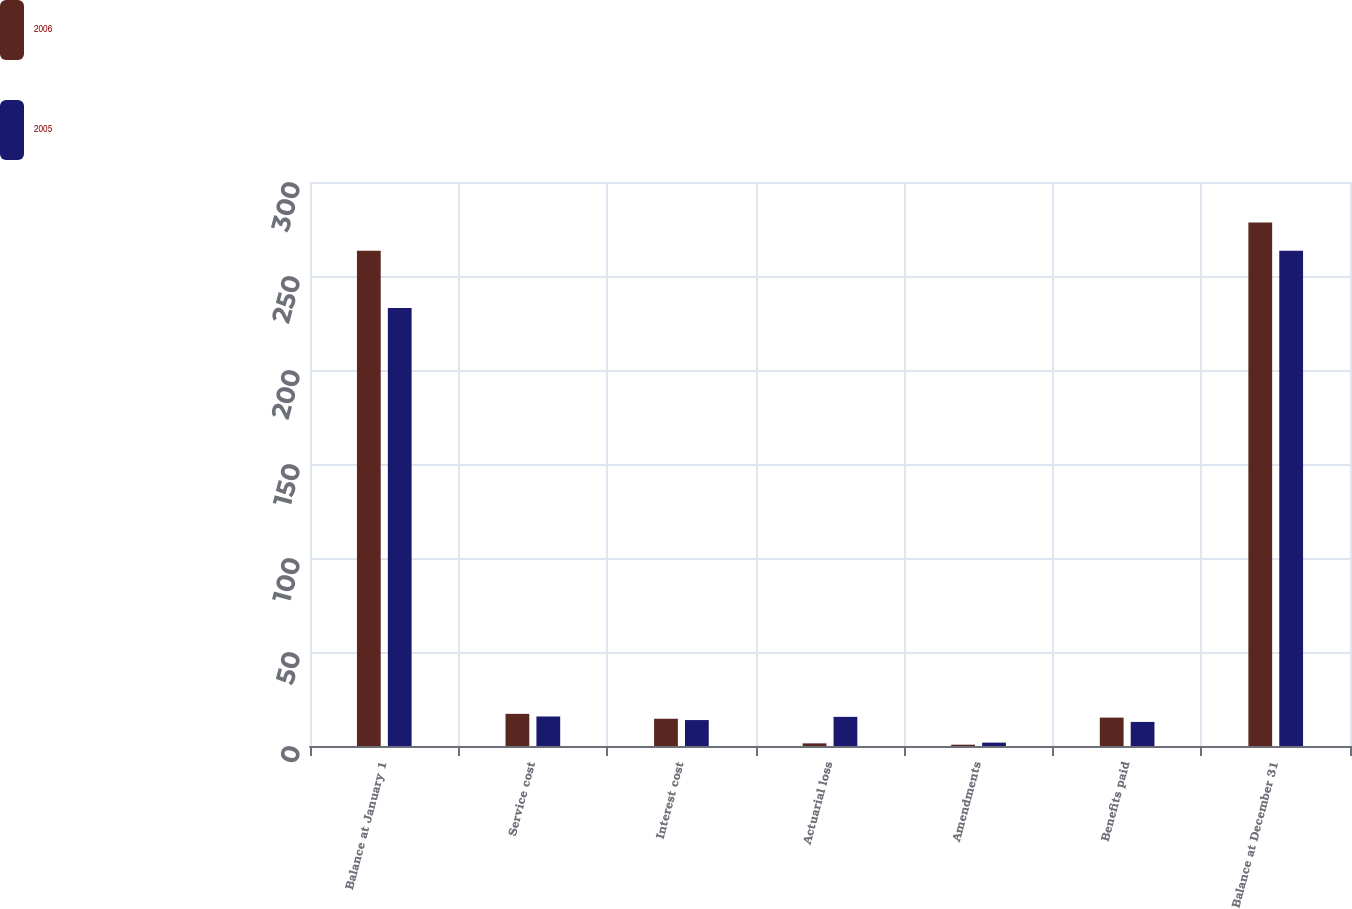Convert chart. <chart><loc_0><loc_0><loc_500><loc_500><stacked_bar_chart><ecel><fcel>Balance at January 1<fcel>Service cost<fcel>Interest cost<fcel>Actuarial loss<fcel>Amendments<fcel>Benefits paid<fcel>Balance at December 31<nl><fcel>2006<fcel>263.4<fcel>17.1<fcel>14.5<fcel>1.4<fcel>0.7<fcel>15.1<fcel>278.5<nl><fcel>2005<fcel>233<fcel>15.7<fcel>13.8<fcel>15.5<fcel>1.8<fcel>12.8<fcel>263.4<nl></chart> 